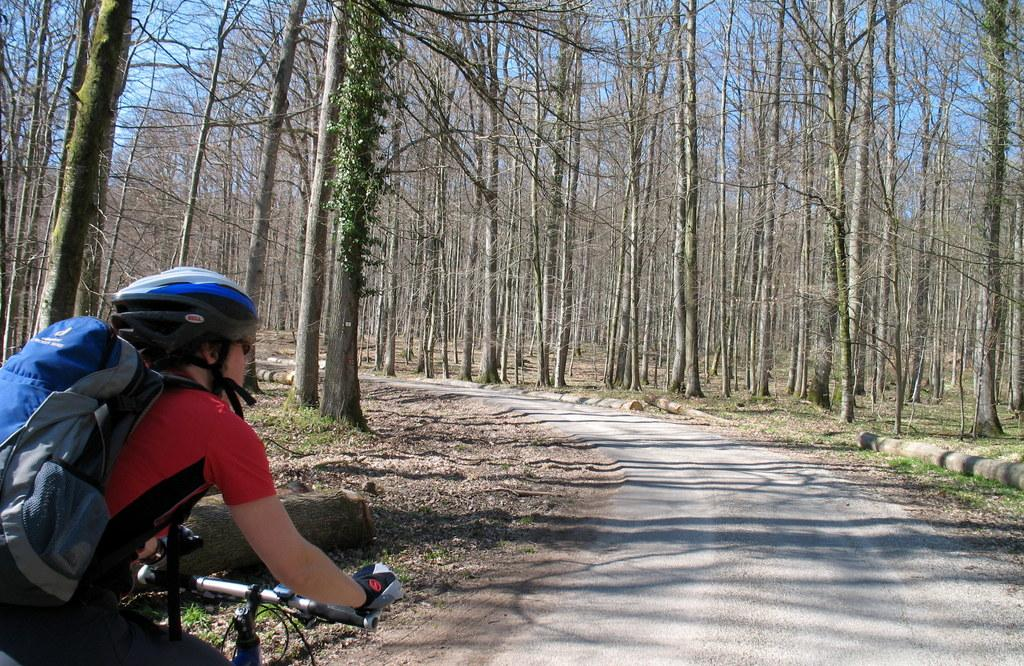Who is present in the image? There is a person in the image. What is the person wearing? The person is wearing a helmet. What activity is the person engaged in? The person is riding a bicycle. Where is the bicycle located? The bicycle is on the road. What can be seen in the background of the image? There are trees visible in the image. What type of ring is the person wearing on their finger in the image? There is no ring visible on the person's finger in the image. How does the baby contribute to the scene in the image? There is no baby present in the image. 